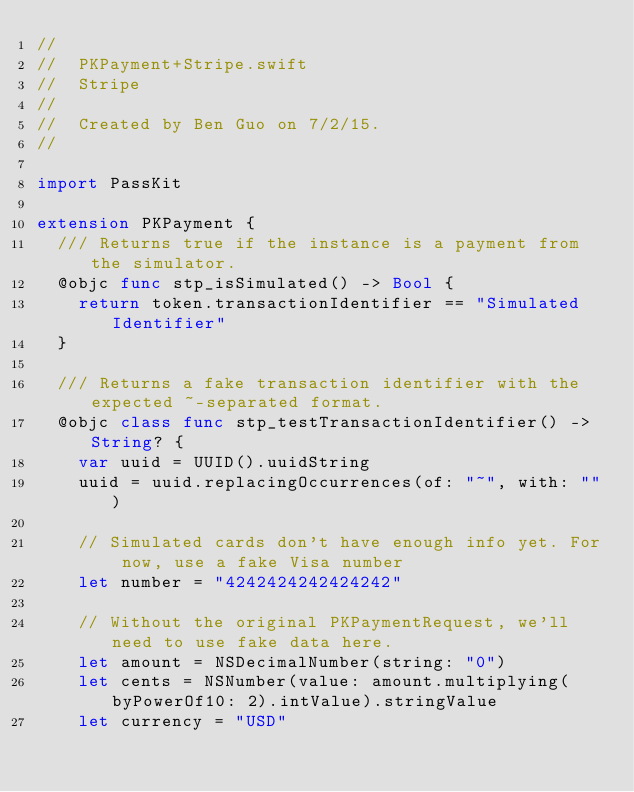<code> <loc_0><loc_0><loc_500><loc_500><_Swift_>//
//  PKPayment+Stripe.swift
//  Stripe
//
//  Created by Ben Guo on 7/2/15.
//

import PassKit

extension PKPayment {
  /// Returns true if the instance is a payment from the simulator.
  @objc func stp_isSimulated() -> Bool {
    return token.transactionIdentifier == "Simulated Identifier"
  }

  /// Returns a fake transaction identifier with the expected ~-separated format.
  @objc class func stp_testTransactionIdentifier() -> String? {
    var uuid = UUID().uuidString
    uuid = uuid.replacingOccurrences(of: "~", with: "")

    // Simulated cards don't have enough info yet. For now, use a fake Visa number
    let number = "4242424242424242"

    // Without the original PKPaymentRequest, we'll need to use fake data here.
    let amount = NSDecimalNumber(string: "0")
    let cents = NSNumber(value: amount.multiplying(byPowerOf10: 2).intValue).stringValue
    let currency = "USD"</code> 